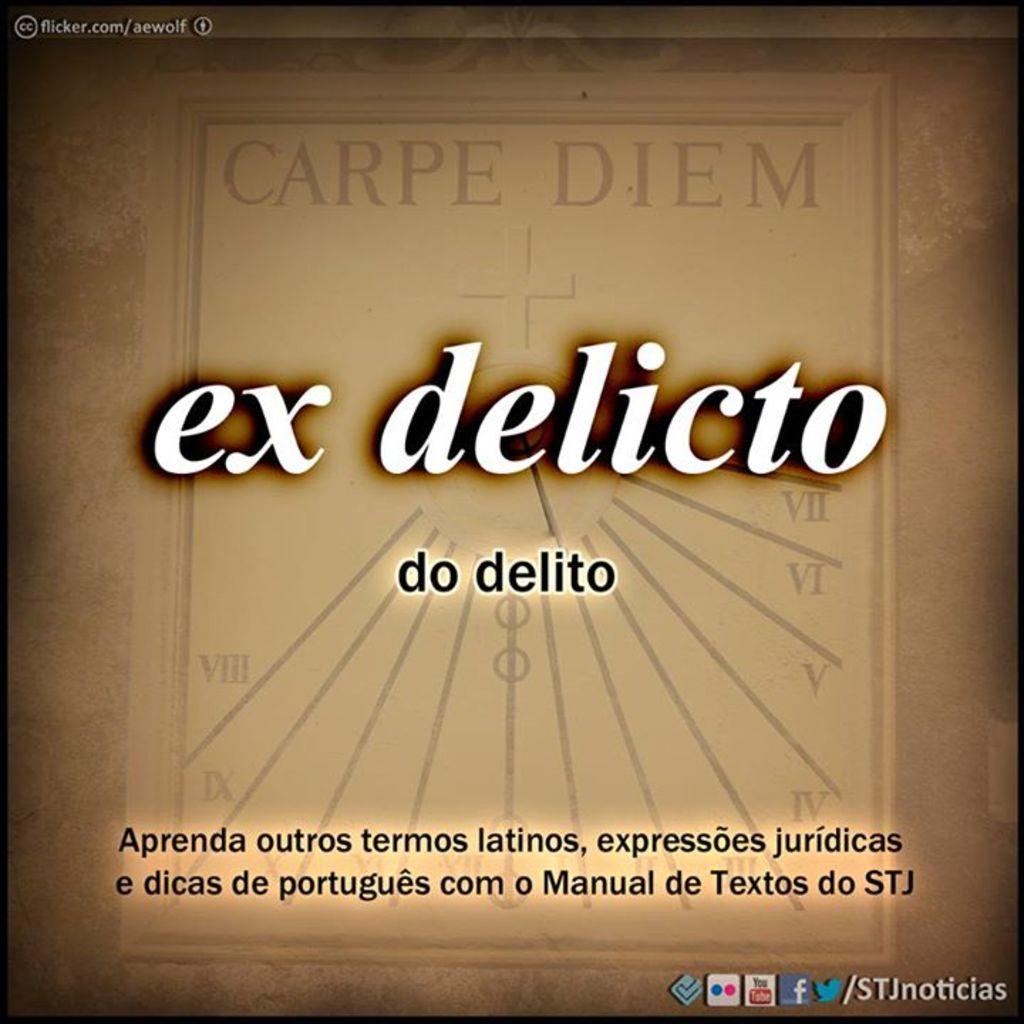What is the name of this?
Keep it short and to the point. Ex delicto. What does the book title say?
Keep it short and to the point. Ex delicto. 